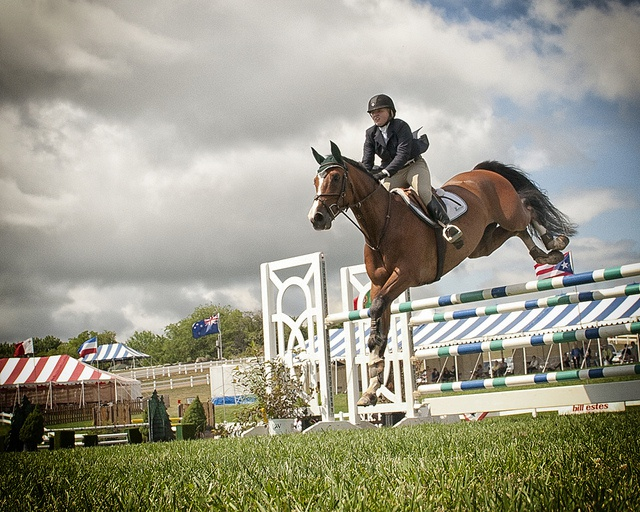Describe the objects in this image and their specific colors. I can see horse in darkgray, black, maroon, and gray tones, people in darkgray, black, gray, and ivory tones, people in darkgray, black, and gray tones, people in darkgray, black, gray, and darkblue tones, and people in darkgray, black, and darkgreen tones in this image. 